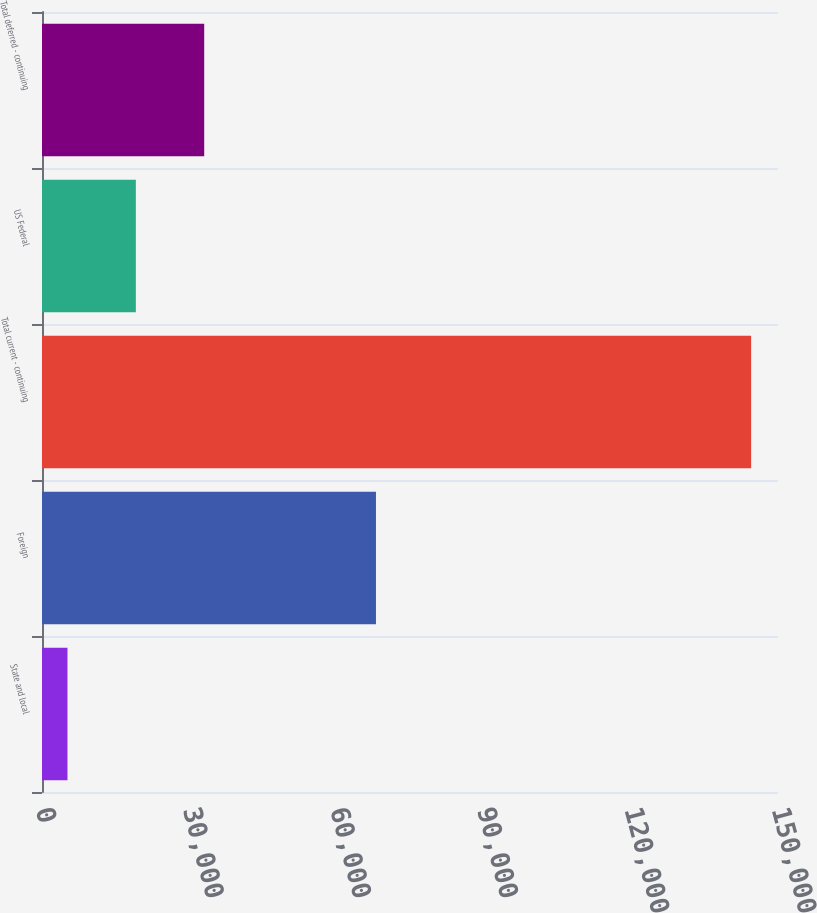<chart> <loc_0><loc_0><loc_500><loc_500><bar_chart><fcel>State and local<fcel>Foreign<fcel>Total current - continuing<fcel>US Federal<fcel>Total deferred - continuing<nl><fcel>5191<fcel>68065<fcel>144525<fcel>19124.4<fcel>33057.8<nl></chart> 